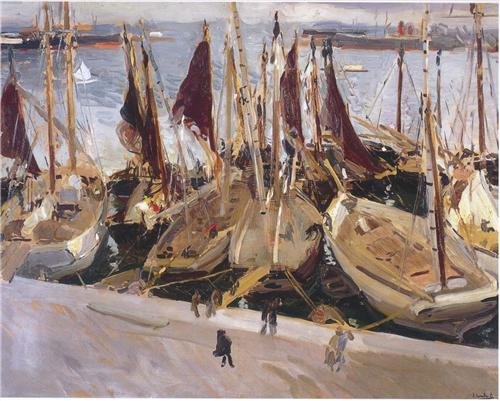Imagine this harbor was transported to Mars. How would it look and what changes would you notice? If this harbor were transported to Mars, the first noticeable change would be the color palette. The clear blue waters would be replaced with a surreal shade of reddish ochre, mirroring the Martian landscape. The sky would be a hazy pink, with two moons faintly visible. The boats, adapted for space travel, would have sleek, metallic designs and solar sails. The figures on the docks would be wearing spacesuits, and the bustling activity would include loading and unloading interplanetary goods with advanced robotics. The distant Martian landscape would feature towering red rock formations and futuristic domed cityscapes, creating a striking contrast with the traditional boats and activities of the harbor. Despite these changes, the essence of a bustling, productive harbor scene would remain, but with a distinctly futuristic and otherworldly twist. 